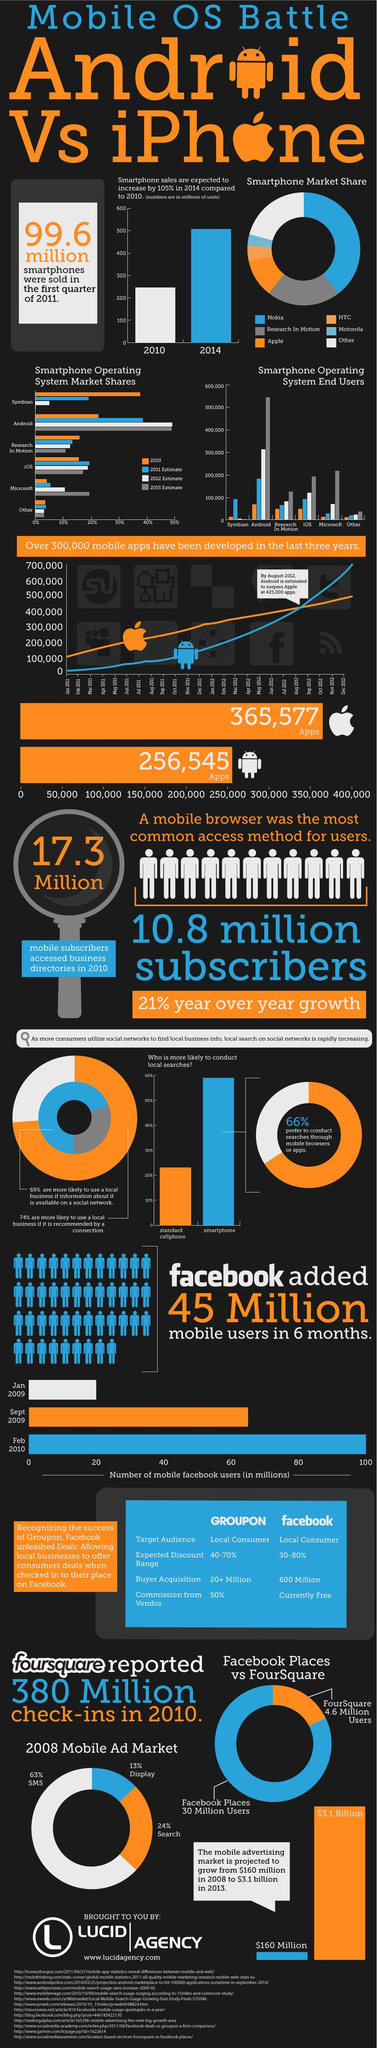Which smartphone operating system has above 500,000 end users in 2015?
Answer the question with a short phrase. Android How many mobile subscribers accessed business directories in 2010? 17.3 Million What is the number of mobile apps developed in Android ? 256,545 Which smartphone operating system has showed the highest market share in 2015? Android What is the number of mobile facebook users (in millions) in February 2010? 100 What is the number of mobile facebook users (in millions) in January 2009? 20 Which year the iOS operating system has shown the highest market share? 2011 Which smartphone operating system has showed the highest market share in 2010? Symbian Which year the Microsoft operating system has shown the highest market share? 2015 Which smartphone operating system has showed the highest market share in 2012? Android 